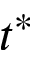<formula> <loc_0><loc_0><loc_500><loc_500>t ^ { * }</formula> 